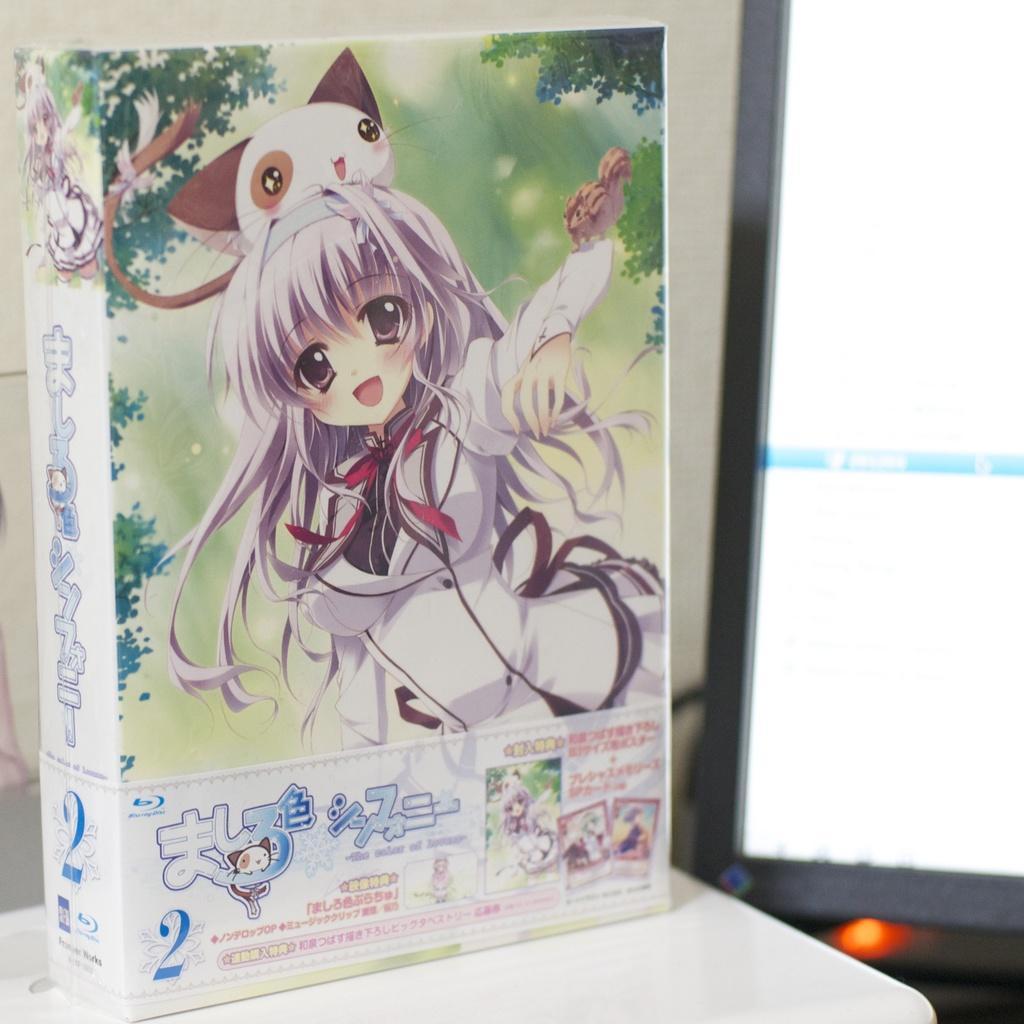How would you summarize this image in a sentence or two? In this picture, it looks like a book on an object. On the book cover, we can see the image of a woman, an animal and trees, there is something written on it. On the right side of the image, there is a monitor and light. Behind the book, it looks like a wall. 